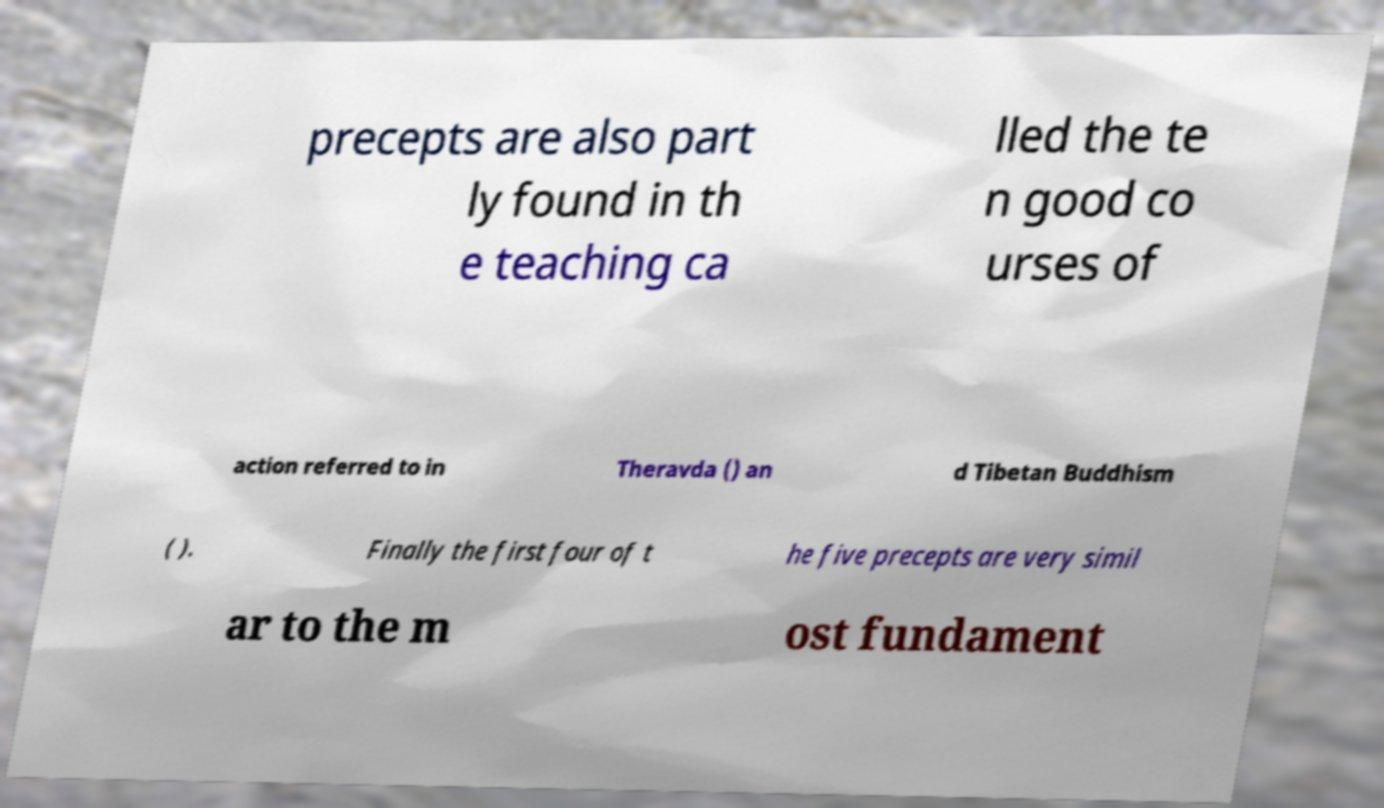Can you accurately transcribe the text from the provided image for me? precepts are also part ly found in th e teaching ca lled the te n good co urses of action referred to in Theravda () an d Tibetan Buddhism ( ). Finally the first four of t he five precepts are very simil ar to the m ost fundament 